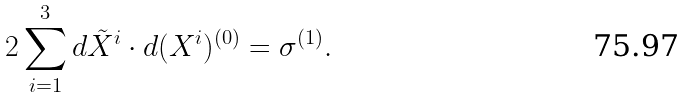<formula> <loc_0><loc_0><loc_500><loc_500>2 \sum _ { i = 1 } ^ { 3 } d \tilde { X } ^ { i } \cdot d ( { X } ^ { i } ) ^ { ( 0 ) } = \sigma ^ { ( 1 ) } .</formula> 